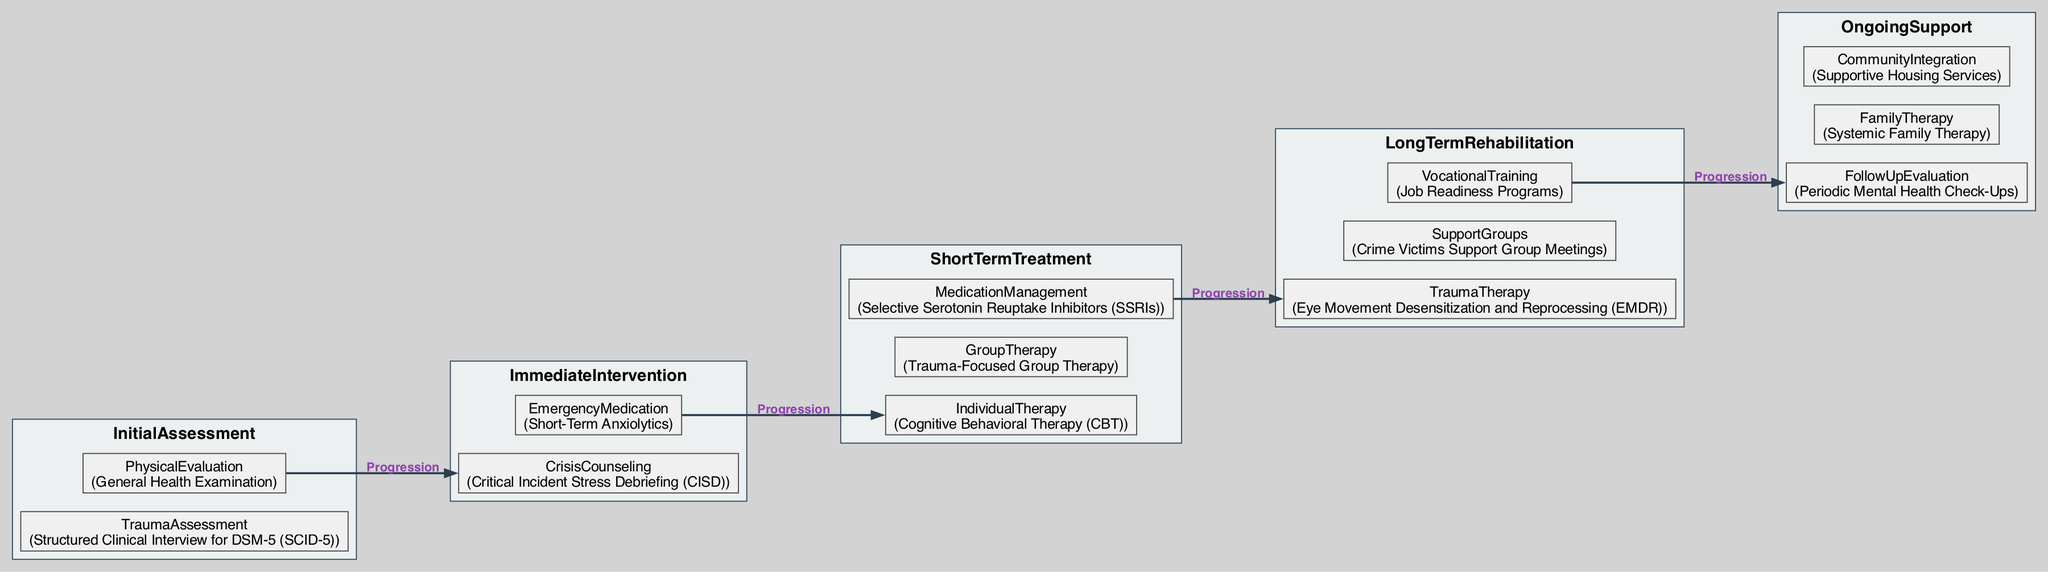What is the first assessment step in the pathway? The first assessment step shown in the diagram is "TraumaAssessment." This is clearly labeled under the "InitialAssessment" stage, indicating that it is the initial focus for evaluating mental health following crime-related trauma.
Answer: TraumaAssessment What type of therapy is used in the short-term treatment phase? In the diagram, "Cognitive Behavioral Therapy (CBT)" is specified as one of the types of therapy used in the short-term treatment phase. This is directly stated under the "ShortTermTreatment" section.
Answer: Cognitive Behavioral Therapy (CBT) How many therapy options are available in short-term treatment? There are three options listed in the "ShortTermTreatment" section: Individual Therapy, Group Therapy, and Medication Management. Counting them gives a total of three options.
Answer: 3 What is the immediate intervention for crisis counseling? The diagram specifies "Critical Incident Stress Debriefing (CISD)" as the intervention for crisis counseling under the "ImmediateIntervention" stage. Therefore, this is the answer to the question.
Answer: Critical Incident Stress Debriefing (CISD) Which phase follows the short-term treatment phase? According to the flow of the diagram, the phase that follows "ShortTermTreatment" is "LongTermRehabilitation." This indicates a progression in the treatment pathway as patients heal and recover.
Answer: LongTermRehabilitation What type of long-term therapy is included in the rehabilitation stage? "Eye Movement Desensitization and Reprocessing (EMDR)" is listed as the long-term therapy in the "LongTermRehabilitation" section, making it the answer to the question.
Answer: Eye Movement Desensitization and Reprocessing (EMDR) What is the purpose of supportive housing services in the ongoing support phase? "Supportive Housing Services" is found in the "OngoingSupport" section and contributes to "CommunityIntegration." This indicates its role in helping victims transition and integrate into community living as part of their rehabilitation.
Answer: CommunityIntegration How does the pathway progress from initial assessment to ongoing support? The pathway flows through consecutive stages: starting from "InitialAssessment," moving to "ImmediateIntervention," then "ShortTermTreatment," followed by "LongTermRehabilitation," and concluding with "OngoingSupport." This sequential nature illustrates how treatment evolves as the individual heals.
Answer: Sequentially through each stage 